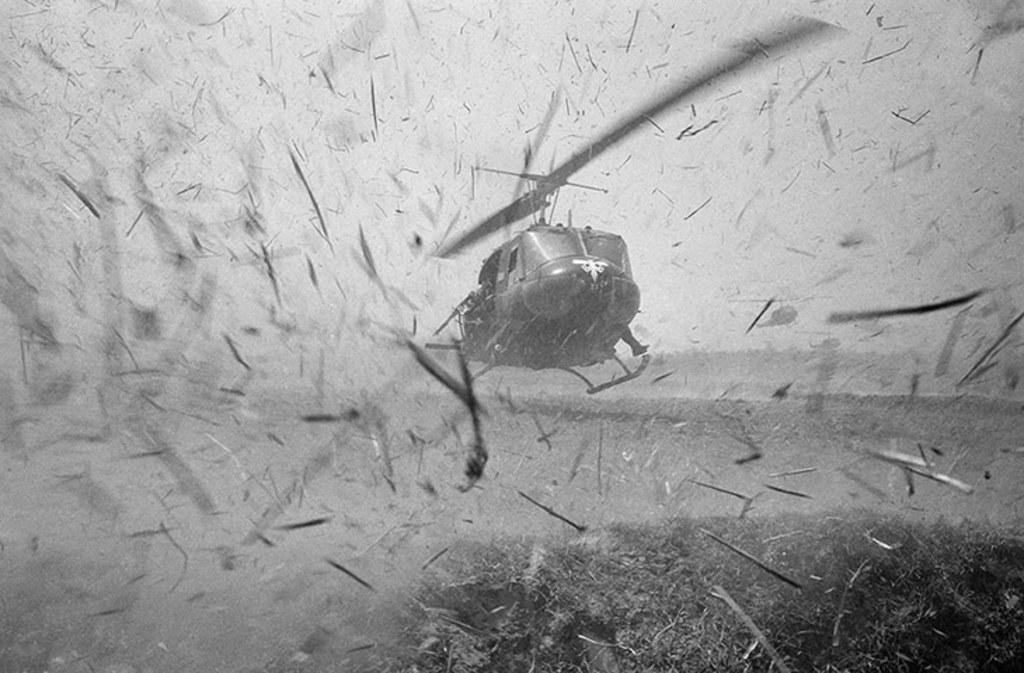How would you summarize this image in a sentence or two? This is a black and white image. In this image we can see a helicopter.   